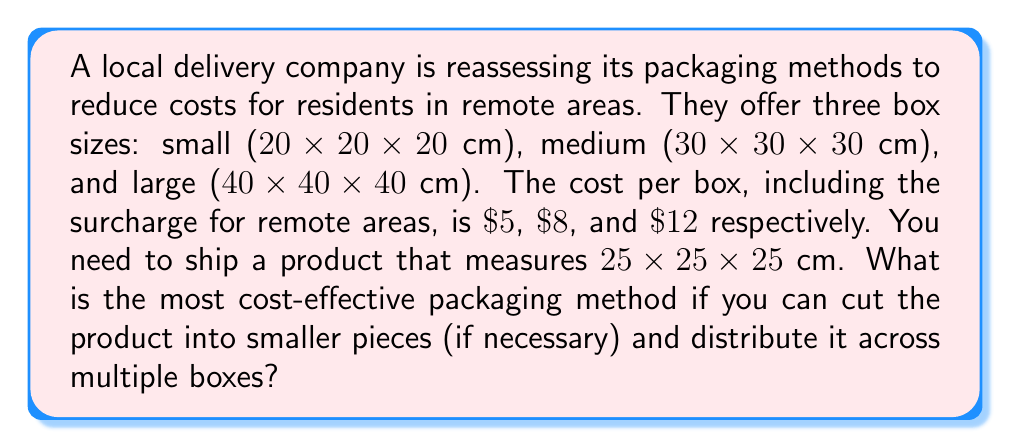Give your solution to this math problem. Let's approach this step-by-step:

1) First, let's calculate the volumes of each box size:
   - Small box: $20 \times 20 \times 20 = 8,000$ cm³
   - Medium box: $30 \times 30 \times 30 = 27,000$ cm³
   - Large box: $40 \times 40 \times 40 = 64,000$ cm³

2) Now, let's calculate the volume of the product:
   $25 \times 25 \times 25 = 15,625$ cm³

3) Let's consider our options:
   a) Use one medium box: Cost = $\$8$
   b) Use one large box: Cost = $\$12$
   c) Cut the product and use multiple small boxes

4) For option c, we need to determine how many small boxes we need:
   $\lceil \frac{15,625}{8,000} \rceil = 2$ boxes
   (We use the ceiling function as we can't use a fractional number of boxes)

5) The cost for option c:
   $2 \times \$5 = \$10$

6) Comparing the costs:
   a) $\$8$
   b) $\$12$
   c) $\$10$

The most cost-effective option is to use one medium box for $\$8$.
Answer: The most cost-effective packaging method is to use one medium box ($30 \times 30 \times 30$ cm) at a cost of $\$8$. 